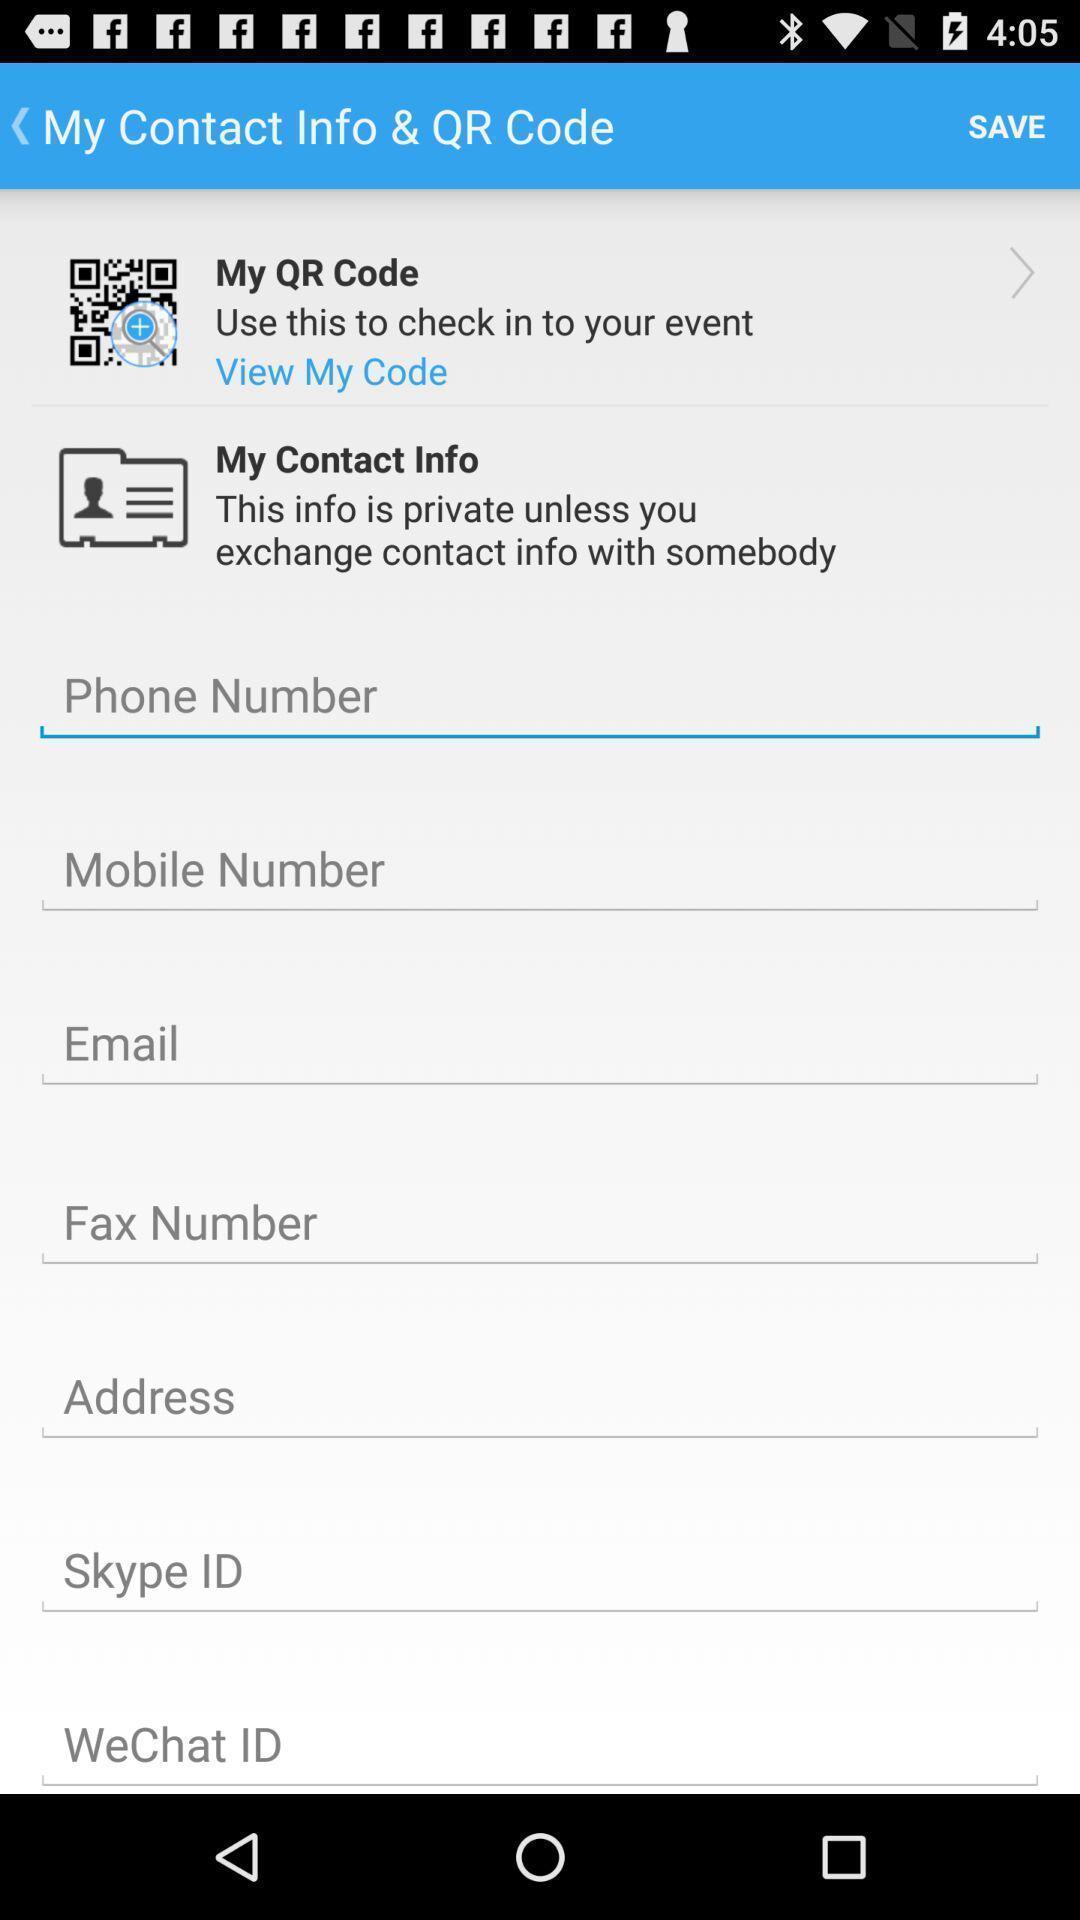What is the overall content of this screenshot? Screen shows the contact details. 